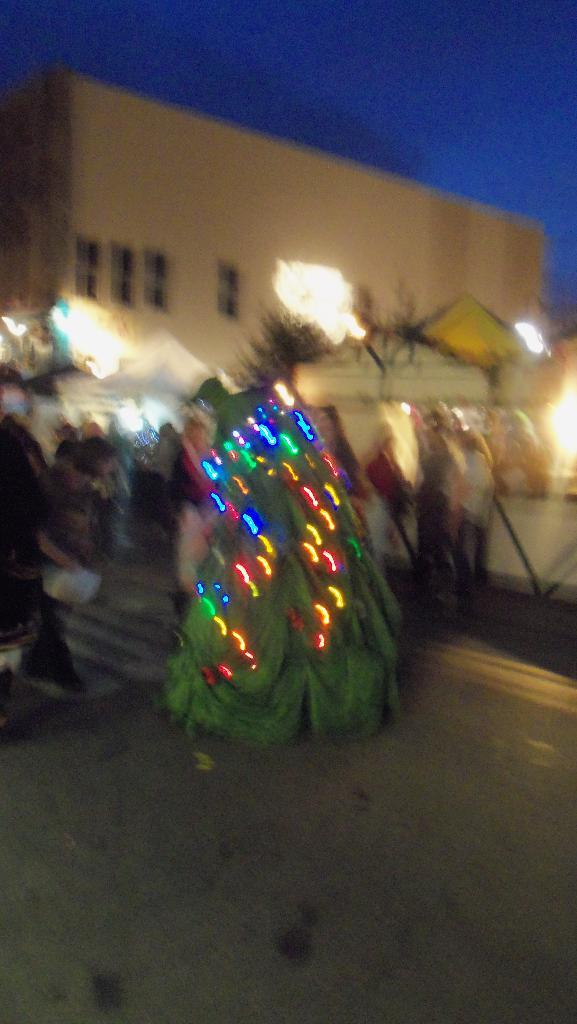What is the main feature of the tree in the image? The tree is decorated with lights in the image. Can you describe the people in the image? There is a group of people in the image. What else can be seen in the background of the image? There are buildings in the image. What is visible in the sky in the image? The sky is visible in the image. What type of wristwatch is the goose wearing in the image? There is no goose or wristwatch present in the image. How does the growth of the tree in the image compare to the growth of the buildings? The provided facts do not mention the growth of the tree or the buildings, so it cannot be compared. 